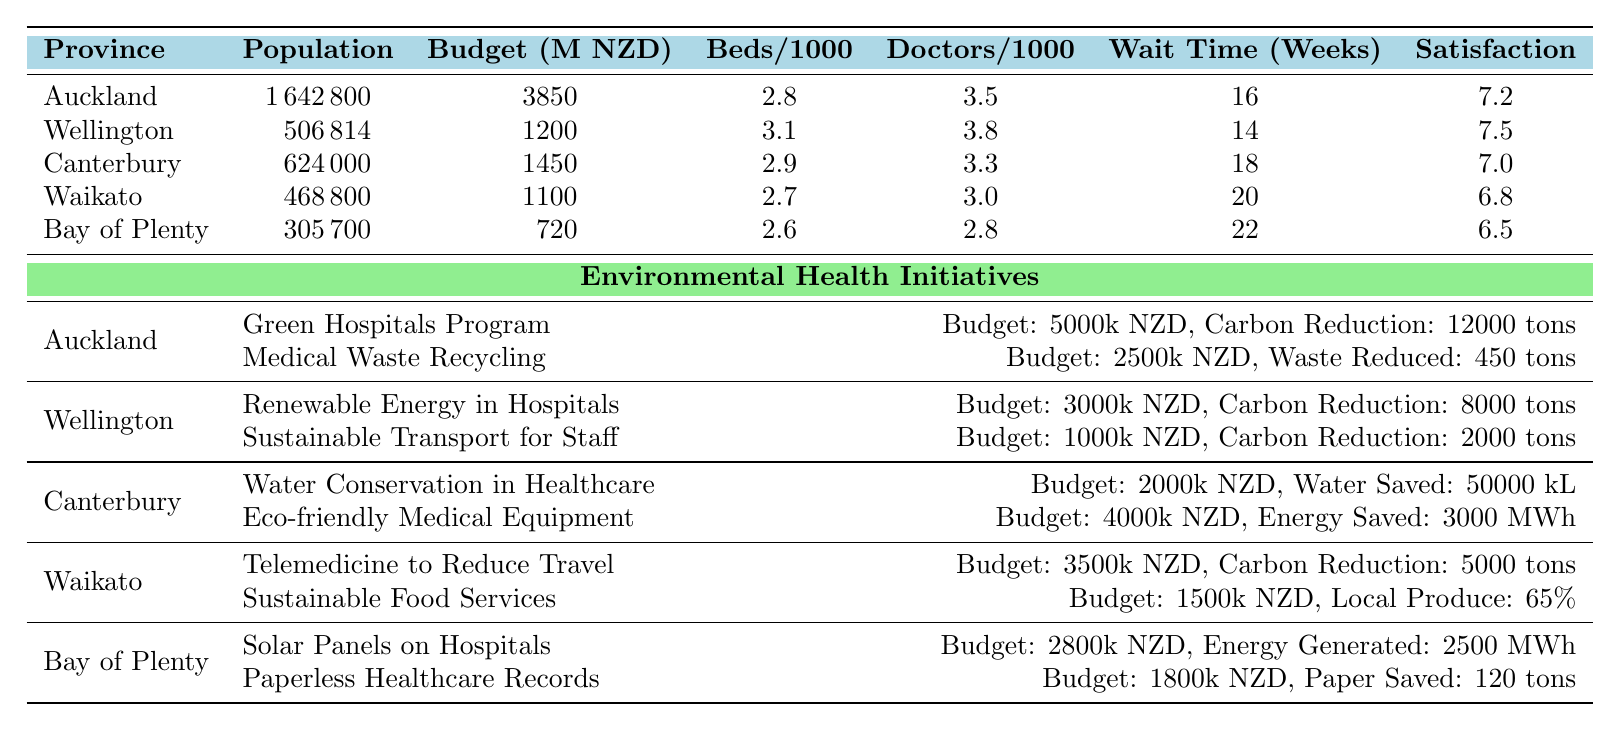What province has the highest healthcare budget? By examining the healthcare budget column, Auckland has the highest budget of NZD 3850 million.
Answer: Auckland Which province has the lowest patient satisfaction score? The patient satisfaction score for Bay of Plenty is the lowest at 6.5, compared to the other provinces.
Answer: Bay of Plenty What is the average wait time for non-urgent surgeries across the provinces? The wait times are 16, 14, 18, 20, and 22 weeks. Adding these values gives 90 weeks, and dividing by 5 provinces gives an average of 18 weeks.
Answer: 18 weeks Does Wellington have more doctors per 1000 people compared to Canterbury? Yes, Wellington has 3.8 doctors per 1000 people, while Canterbury has only 3.3 doctors.
Answer: Yes Which province has the greatest carbon reduction from environmental health initiatives? Auckland has the highest carbon reduction of 12,000 tons from the Green Hospitals Program, which is greater than the reductions from Wellington, Canterbury, Waikato, and Bay of Plenty.
Answer: Auckland What is the total carbon reduction for Waikato? Waikato has a carbon reduction of 5000 tons from the Telemedicine initiative. There are no additional related initiatives listed, so the total is just 5000 tons.
Answer: 5000 tons Which province has the most hospital beds per 1000 people? Wellington has the most hospital beds per 1000 people with 3.1, compared to the other provinces listed.
Answer: Wellington How much budget does Canterbury allocate for eco-friendly medical equipment? The annual budget allocated by Canterbury for eco-friendly medical equipment is NZD 4000 thousands.
Answer: NZD 4000 thousands If the average patient satisfaction score is 7.2, which provinces score below this average? The patient satisfaction scores are 7.2 (Auckland), 7.5 (Wellington), 7.0 (Canterbury), 6.8 (Waikato), and 6.5 (Bay of Plenty). The provinces scoring below the average are Canterbury, Waikato, and Bay of Plenty.
Answer: Canterbury, Waikato, Bay of Plenty In terms of sustainable transport for staff, what is the budget for this initiative in Wellington? The budget for the sustainable transport initiative in Wellington is NZD 1000 thousands.
Answer: NZD 1000 thousands 